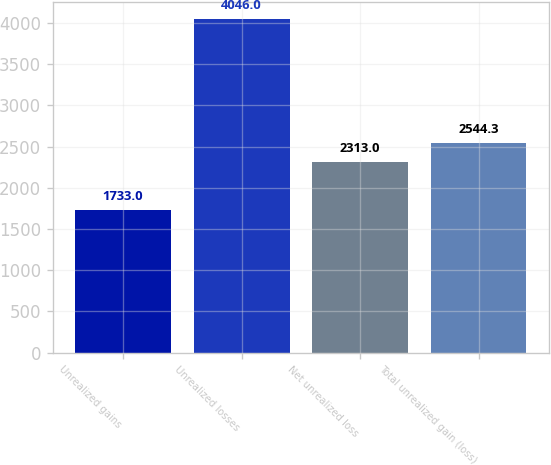<chart> <loc_0><loc_0><loc_500><loc_500><bar_chart><fcel>Unrealized gains<fcel>Unrealized losses<fcel>Net unrealized loss<fcel>Total unrealized gain (loss)<nl><fcel>1733<fcel>4046<fcel>2313<fcel>2544.3<nl></chart> 